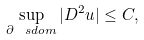<formula> <loc_0><loc_0><loc_500><loc_500>\sup _ { \partial \ s d o m } | D ^ { 2 } u | \leq C ,</formula> 